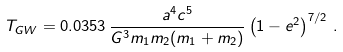Convert formula to latex. <formula><loc_0><loc_0><loc_500><loc_500>T _ { G W } = 0 . 0 3 5 3 \, \frac { a ^ { 4 } c ^ { 5 } } { G ^ { 3 } m _ { 1 } m _ { 2 } ( m _ { 1 } + m _ { 2 } ) } \left ( 1 - e ^ { 2 } \right ) ^ { 7 / 2 } \, .</formula> 